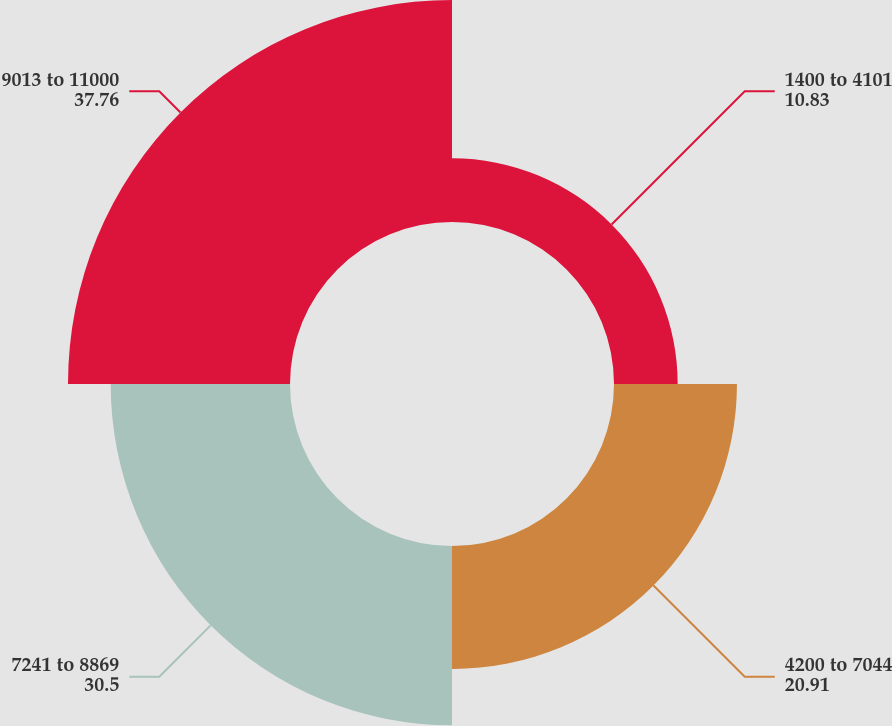Convert chart. <chart><loc_0><loc_0><loc_500><loc_500><pie_chart><fcel>1400 to 4101<fcel>4200 to 7044<fcel>7241 to 8869<fcel>9013 to 11000<nl><fcel>10.83%<fcel>20.91%<fcel>30.5%<fcel>37.76%<nl></chart> 